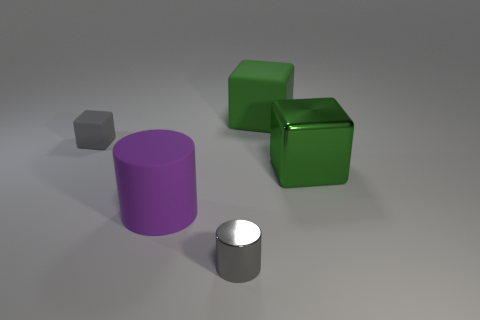Add 2 big cylinders. How many objects exist? 7 Subtract all blocks. How many objects are left? 2 Add 4 metallic things. How many metallic things exist? 6 Subtract 0 yellow cylinders. How many objects are left? 5 Subtract all brown objects. Subtract all big green matte things. How many objects are left? 4 Add 3 tiny shiny objects. How many tiny shiny objects are left? 4 